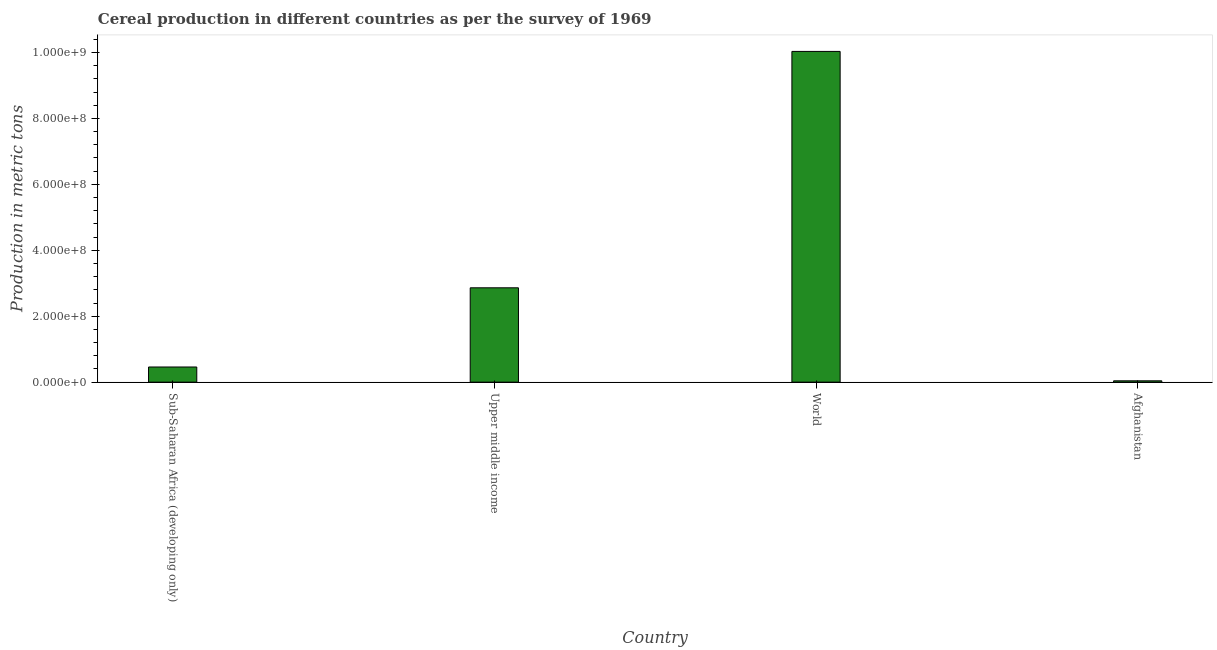Does the graph contain any zero values?
Offer a very short reply. No. What is the title of the graph?
Give a very brief answer. Cereal production in different countries as per the survey of 1969. What is the label or title of the X-axis?
Give a very brief answer. Country. What is the label or title of the Y-axis?
Keep it short and to the point. Production in metric tons. What is the cereal production in Upper middle income?
Provide a succinct answer. 2.86e+08. Across all countries, what is the maximum cereal production?
Offer a terse response. 1.00e+09. Across all countries, what is the minimum cereal production?
Offer a very short reply. 4.04e+06. In which country was the cereal production maximum?
Keep it short and to the point. World. In which country was the cereal production minimum?
Provide a short and direct response. Afghanistan. What is the sum of the cereal production?
Your answer should be very brief. 1.34e+09. What is the difference between the cereal production in Sub-Saharan Africa (developing only) and World?
Keep it short and to the point. -9.57e+08. What is the average cereal production per country?
Ensure brevity in your answer.  3.35e+08. What is the median cereal production?
Your answer should be compact. 1.66e+08. What is the ratio of the cereal production in Afghanistan to that in Sub-Saharan Africa (developing only)?
Offer a very short reply. 0.09. What is the difference between the highest and the second highest cereal production?
Offer a very short reply. 7.17e+08. What is the difference between the highest and the lowest cereal production?
Your response must be concise. 9.99e+08. Are all the bars in the graph horizontal?
Keep it short and to the point. No. What is the Production in metric tons of Sub-Saharan Africa (developing only)?
Give a very brief answer. 4.60e+07. What is the Production in metric tons in Upper middle income?
Offer a very short reply. 2.86e+08. What is the Production in metric tons of World?
Give a very brief answer. 1.00e+09. What is the Production in metric tons of Afghanistan?
Your response must be concise. 4.04e+06. What is the difference between the Production in metric tons in Sub-Saharan Africa (developing only) and Upper middle income?
Provide a succinct answer. -2.40e+08. What is the difference between the Production in metric tons in Sub-Saharan Africa (developing only) and World?
Ensure brevity in your answer.  -9.57e+08. What is the difference between the Production in metric tons in Sub-Saharan Africa (developing only) and Afghanistan?
Keep it short and to the point. 4.19e+07. What is the difference between the Production in metric tons in Upper middle income and World?
Your answer should be very brief. -7.17e+08. What is the difference between the Production in metric tons in Upper middle income and Afghanistan?
Offer a terse response. 2.82e+08. What is the difference between the Production in metric tons in World and Afghanistan?
Ensure brevity in your answer.  9.99e+08. What is the ratio of the Production in metric tons in Sub-Saharan Africa (developing only) to that in Upper middle income?
Your answer should be very brief. 0.16. What is the ratio of the Production in metric tons in Sub-Saharan Africa (developing only) to that in World?
Give a very brief answer. 0.05. What is the ratio of the Production in metric tons in Sub-Saharan Africa (developing only) to that in Afghanistan?
Provide a short and direct response. 11.38. What is the ratio of the Production in metric tons in Upper middle income to that in World?
Offer a very short reply. 0.28. What is the ratio of the Production in metric tons in Upper middle income to that in Afghanistan?
Offer a terse response. 70.86. What is the ratio of the Production in metric tons in World to that in Afghanistan?
Offer a very short reply. 248.44. 